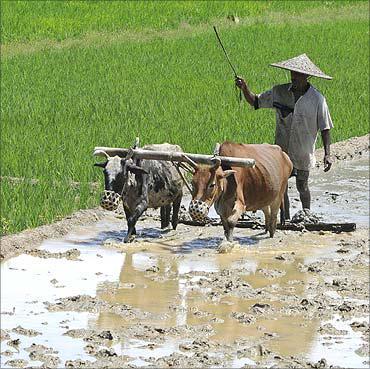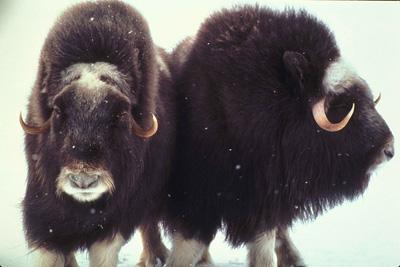The first image is the image on the left, the second image is the image on the right. Evaluate the accuracy of this statement regarding the images: "An image shows a man wielding a stick behind a plow pulled by two cattle.". Is it true? Answer yes or no. Yes. The first image is the image on the left, the second image is the image on the right. Given the left and right images, does the statement "In one image, a farmer is guiding a plow that two animals with horns are pulling through a watery field." hold true? Answer yes or no. Yes. 